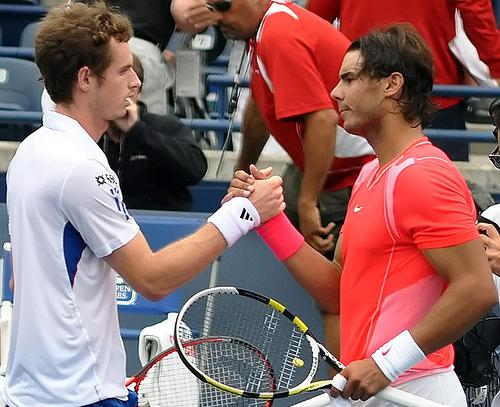What are the people in the image feeling or expressing? The participants may be expressing sportsmanship and camaraderie after a competitive event. What type of event is depicted in the image? A sporting event featuring tennis players. Assess the quality of the image based on the inclusion of objects and subjects. The image appears to be of high quality, showcasing diverse objects like tennis rackets and wristbands, and multiple players with clear interaction and context. What are some recognizable logos on the wristbands and shirts? There is a white Nike sign on a red shirt, a pink Nike sign on a wristband, and a black design on a white armband. How do the men in the image look?  They are young athletic men, one with brown hair. Count the number of wrist bands in the image. There are nine wrist bands in total. What types of tennis racket colors can be seen in the image? There are red and black, white and yellow, and yellow black and white tennis rackets. Provide a brief analysis of how objects and subjects interact in the image. The subjects, two young athletic men, interact by shaking hands after a tennis match, while holding colorfully designed tennis rackets. Describe the colors and brands of the athletic apparel worn by the participants. There is a man wearing a red and pink short-sleeve Nike shirt with a white Nike sign, a white shirt with a blue stripe, a red wristband, and another wearing a white shirt with black lettering and a blue patch.  What are two men in the image doing together? Two men are shaking hands, likely after a tennis match. Identify a facial feature showcased in the image. the nose of a man Can you locate a dog in the image? No, it's not mentioned in the image. Create a picturesque description of a man holding a tennis racket in the image. A focused athlete gripping a tennis racket, poised to make his next move in the heat of competition. What is the main scenario happening in the given photograph which involves two men? two tennis players shaking hands Can you find the man wearing a green shirt in the image? This instruction is misleading because there is no mention of a man wearing a green shirt, only men wearing red, white, and black shirts. Which person is wearing a white wristband and a white shirt in the image? man wearing white shirt What color are the shorts being worn by the man in the white shirt? white Express a sentence that grounds a man wearing a white and blue shirt in the image. A man with a casual yet stylish appearance is wearing a white shirt with a blue stripe. Out of these options, which object is found on a man's arm in the image? A. Pink wrist band B. White wristband C. Red wristband D. None of the above A. Pink wrist band Describe an activity that could be taking place if a man is wearing a white wristband and holding a tennis racket. playing tennis Compose a vivid depiction of the event occuring in the image. Tensions are high as two athletic men face each other on the tennis court, shaking hands before commencing an intense match. Is there an orange wristband in the image? This is misleading because there is no mention of an orange wristband, only wristbands in other colors like white, black, pink, and red. Point out a noteworthy detail about the red shirt worn by one of the men in the image. It has a white Nike sign on it. At the location of the man holding the tennis racket, which color is likely to be dominating the scene? A. Red B. Green C. Blue D. Orange A. Red Is the racket with the white and blue colors in the image? The instruction is misleading because there is no mention of a white and blue racket, only a yellow black and white one and a red and black one. State the expression worn by the man with brown hair. game face Impart a brief description of an athlete's attire seen in the image. A sporty individual wearing a red and pink shortsleeve Nike shirt. In the image, derive a possible emotion being displayed by the man with brown hair. determination Describe the interaction taking place between two individuals in the image. two men shaking hands Examine the image and determine an object associated with a black jacket. longsleeve black jacket Which object has a pink Nike sign on it? a wrist band 